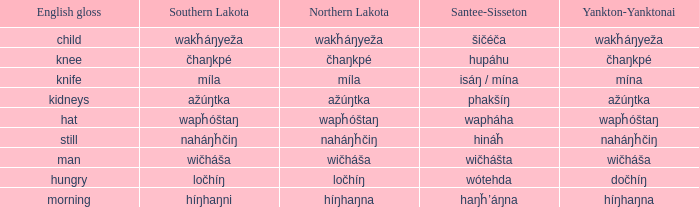Name the number of english gloss for wakȟáŋyeža 1.0. 